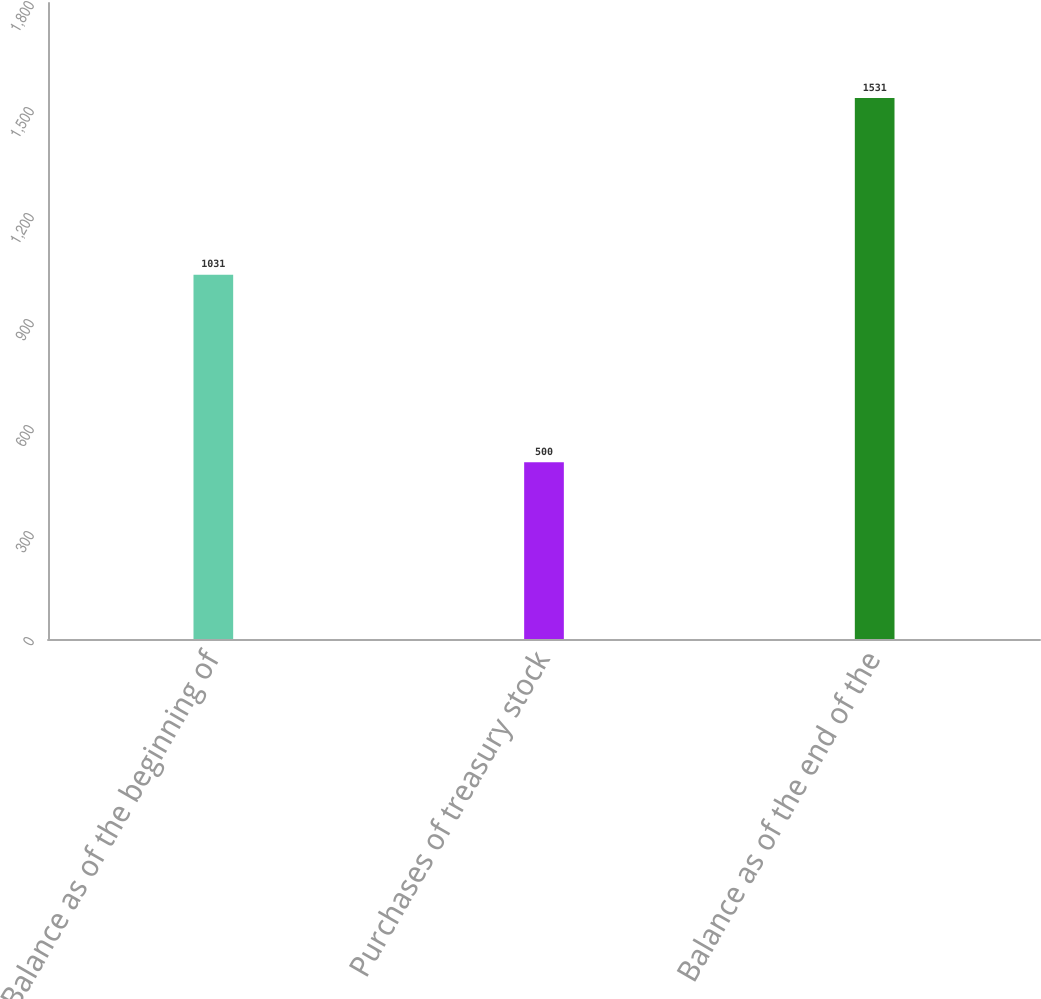<chart> <loc_0><loc_0><loc_500><loc_500><bar_chart><fcel>Balance as of the beginning of<fcel>Purchases of treasury stock<fcel>Balance as of the end of the<nl><fcel>1031<fcel>500<fcel>1531<nl></chart> 